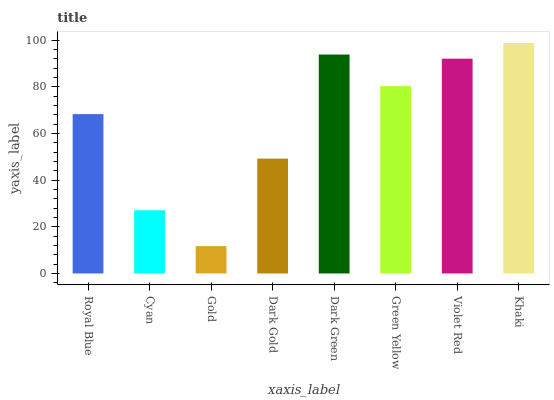Is Gold the minimum?
Answer yes or no. Yes. Is Khaki the maximum?
Answer yes or no. Yes. Is Cyan the minimum?
Answer yes or no. No. Is Cyan the maximum?
Answer yes or no. No. Is Royal Blue greater than Cyan?
Answer yes or no. Yes. Is Cyan less than Royal Blue?
Answer yes or no. Yes. Is Cyan greater than Royal Blue?
Answer yes or no. No. Is Royal Blue less than Cyan?
Answer yes or no. No. Is Green Yellow the high median?
Answer yes or no. Yes. Is Royal Blue the low median?
Answer yes or no. Yes. Is Gold the high median?
Answer yes or no. No. Is Violet Red the low median?
Answer yes or no. No. 